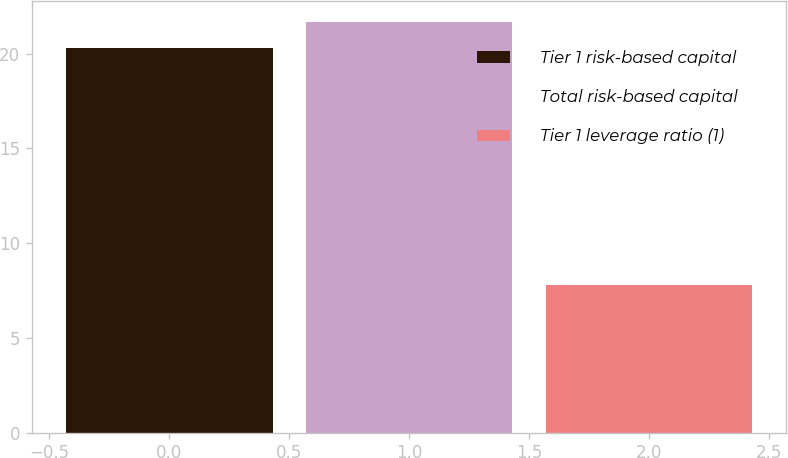<chart> <loc_0><loc_0><loc_500><loc_500><bar_chart><fcel>Tier 1 risk-based capital<fcel>Total risk-based capital<fcel>Tier 1 leverage ratio (1)<nl><fcel>20.3<fcel>21.68<fcel>7.8<nl></chart> 